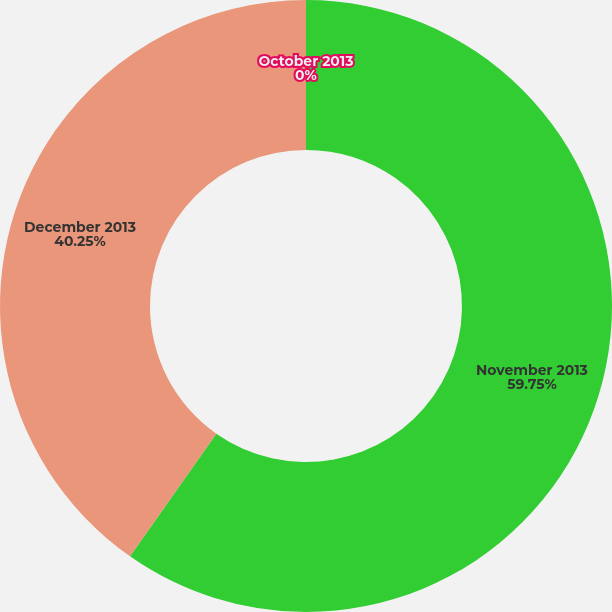Convert chart. <chart><loc_0><loc_0><loc_500><loc_500><pie_chart><fcel>October 2013<fcel>November 2013<fcel>December 2013<nl><fcel>0.0%<fcel>59.75%<fcel>40.25%<nl></chart> 